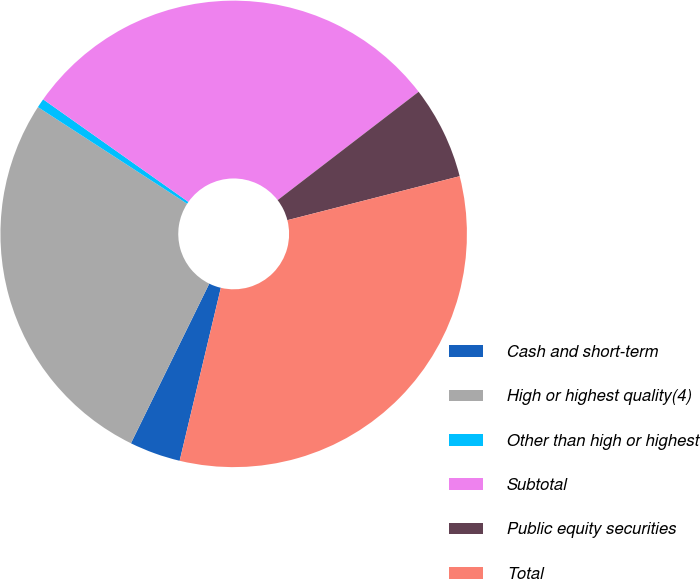Convert chart to OTSL. <chart><loc_0><loc_0><loc_500><loc_500><pie_chart><fcel>Cash and short-term<fcel>High or highest quality(4)<fcel>Other than high or highest<fcel>Subtotal<fcel>Public equity securities<fcel>Total<nl><fcel>3.54%<fcel>26.89%<fcel>0.64%<fcel>29.79%<fcel>6.45%<fcel>32.7%<nl></chart> 